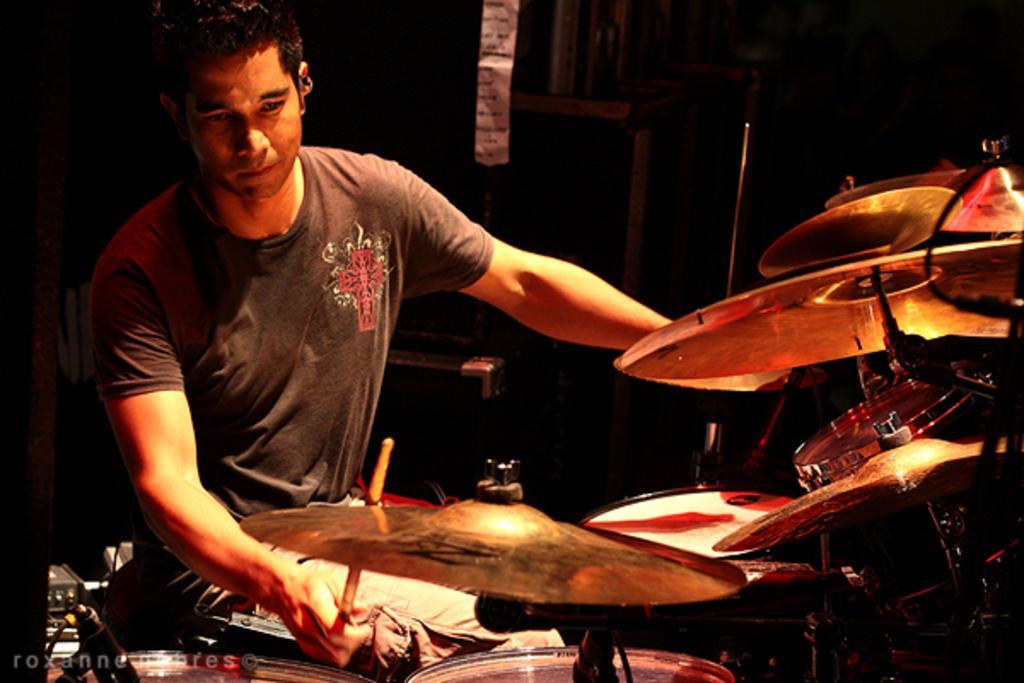In one or two sentences, can you explain what this image depicts? In this picture I can see a man playing drums and he is holding a stick in his hand and text at the bottom left corner of the picture and looks like a speaker and a wooden wall in the background. 